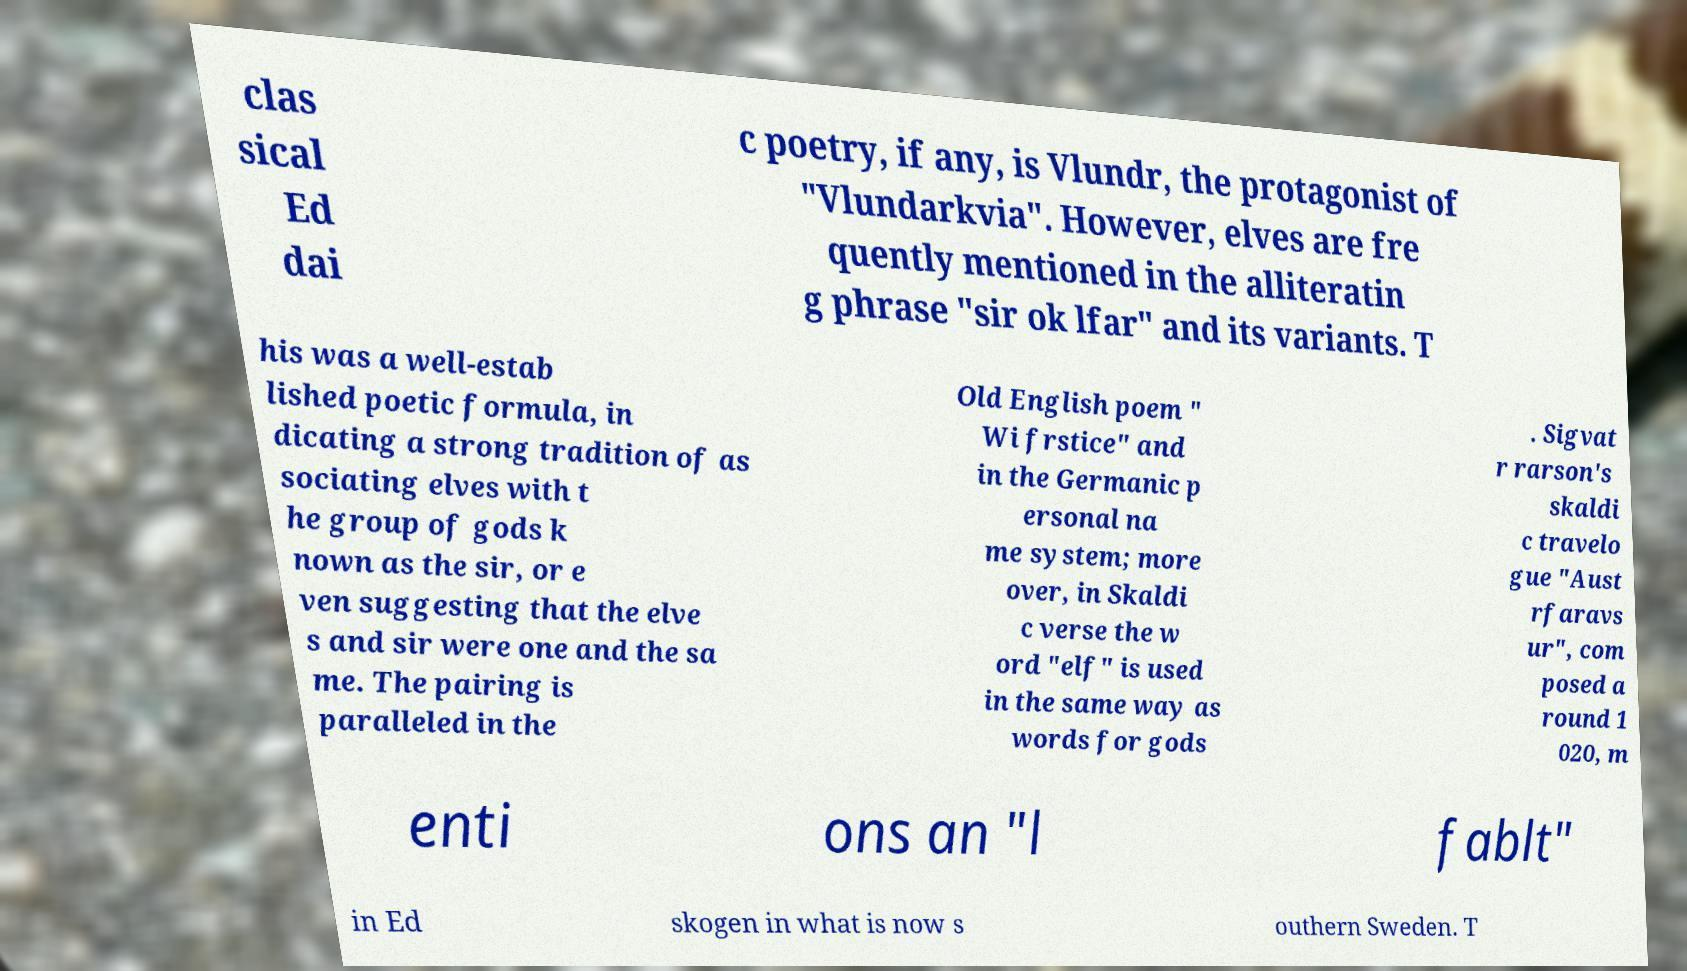I need the written content from this picture converted into text. Can you do that? clas sical Ed dai c poetry, if any, is Vlundr, the protagonist of "Vlundarkvia". However, elves are fre quently mentioned in the alliteratin g phrase "sir ok lfar" and its variants. T his was a well-estab lished poetic formula, in dicating a strong tradition of as sociating elves with t he group of gods k nown as the sir, or e ven suggesting that the elve s and sir were one and the sa me. The pairing is paralleled in the Old English poem " Wi frstice" and in the Germanic p ersonal na me system; more over, in Skaldi c verse the w ord "elf" is used in the same way as words for gods . Sigvat r rarson's skaldi c travelo gue "Aust rfaravs ur", com posed a round 1 020, m enti ons an "l fablt" in Ed skogen in what is now s outhern Sweden. T 